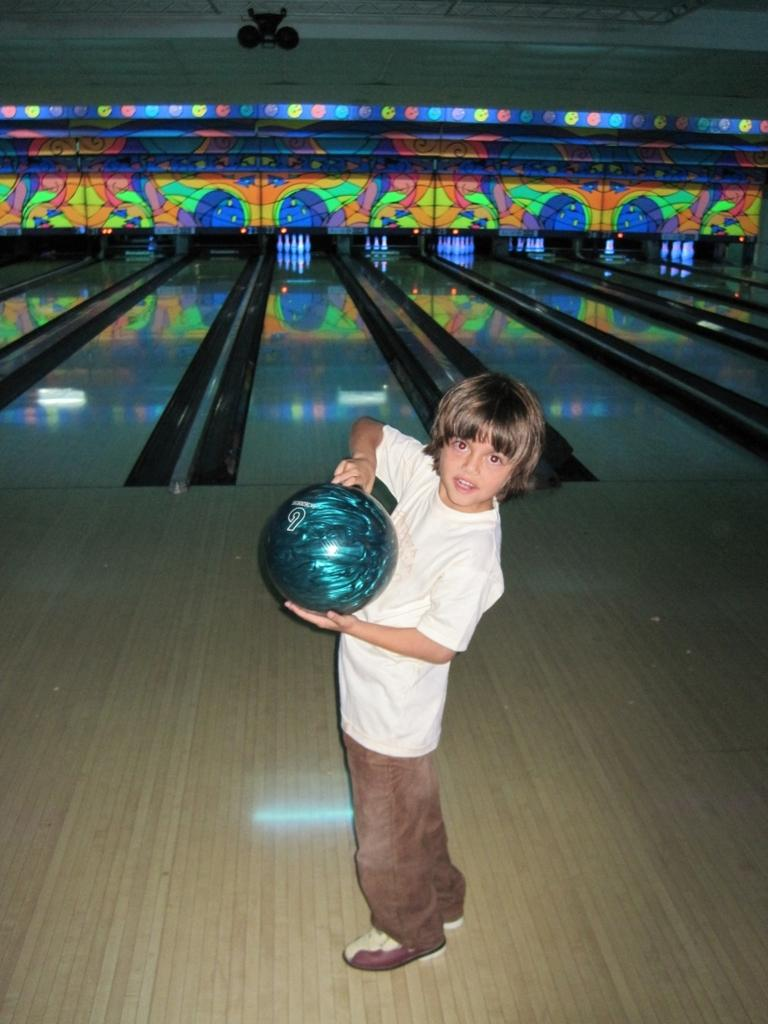Who is the main subject in the image? There is a boy in the image. What is the boy holding in his hands? The boy is holding a ball in his hands. What can be seen on the floor in the background of the image? There are white color objects on the floor in the background of the image. How do the rabbits in the image show respect to the boy? There are no rabbits present in the image, so they cannot show respect to the boy. 